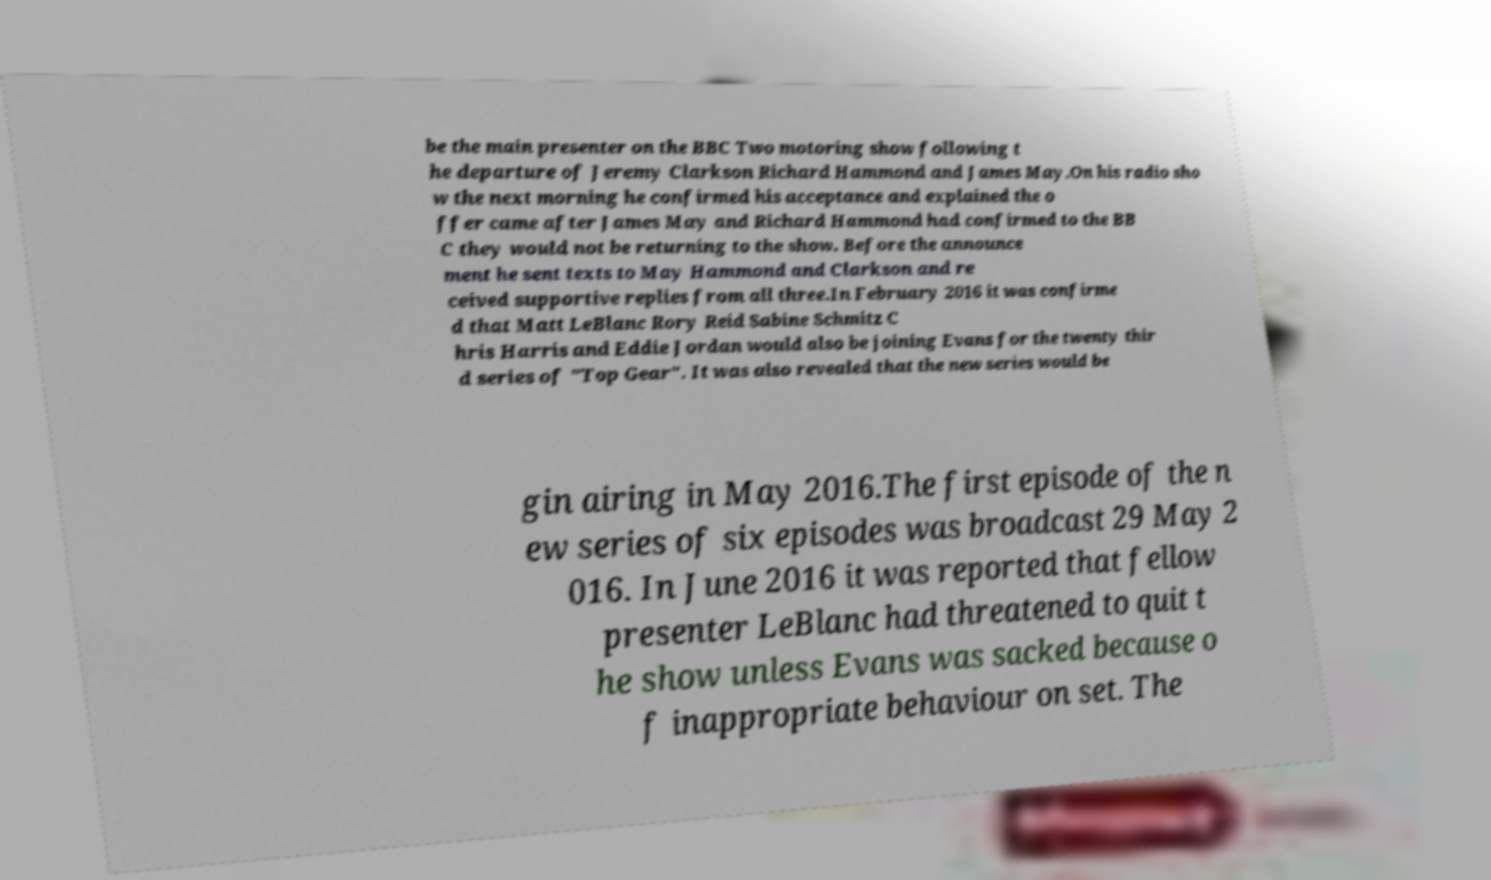There's text embedded in this image that I need extracted. Can you transcribe it verbatim? be the main presenter on the BBC Two motoring show following t he departure of Jeremy Clarkson Richard Hammond and James May.On his radio sho w the next morning he confirmed his acceptance and explained the o ffer came after James May and Richard Hammond had confirmed to the BB C they would not be returning to the show. Before the announce ment he sent texts to May Hammond and Clarkson and re ceived supportive replies from all three.In February 2016 it was confirme d that Matt LeBlanc Rory Reid Sabine Schmitz C hris Harris and Eddie Jordan would also be joining Evans for the twenty thir d series of "Top Gear". It was also revealed that the new series would be gin airing in May 2016.The first episode of the n ew series of six episodes was broadcast 29 May 2 016. In June 2016 it was reported that fellow presenter LeBlanc had threatened to quit t he show unless Evans was sacked because o f inappropriate behaviour on set. The 